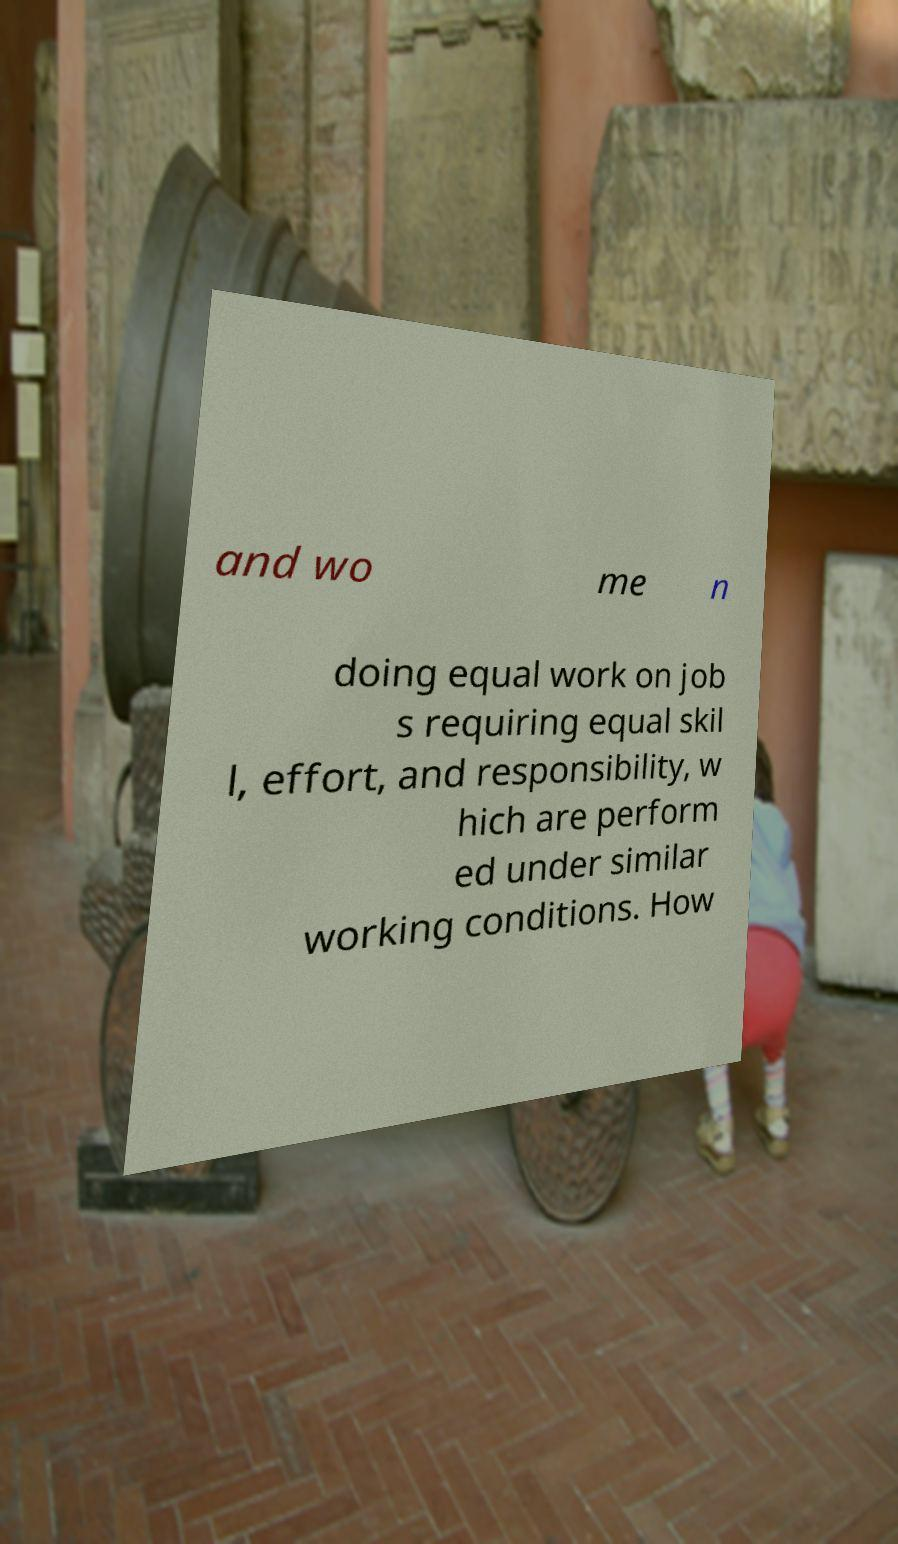I need the written content from this picture converted into text. Can you do that? and wo me n doing equal work on job s requiring equal skil l, effort, and responsibility, w hich are perform ed under similar working conditions. How 